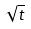<formula> <loc_0><loc_0><loc_500><loc_500>\sqrt { t }</formula> 